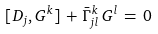Convert formula to latex. <formula><loc_0><loc_0><loc_500><loc_500>[ D _ { j } , G ^ { k } ] \, + \, \bar { \Gamma } ^ { k } _ { j l } \, G ^ { l } \, = \, 0</formula> 